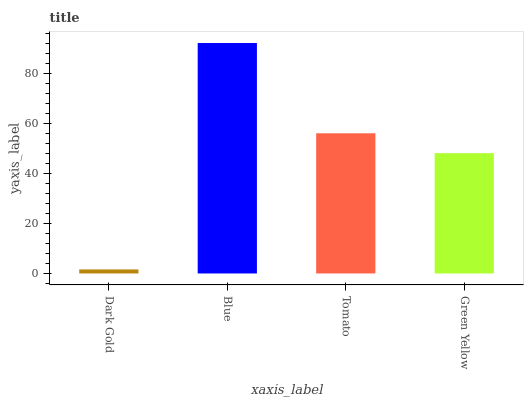Is Dark Gold the minimum?
Answer yes or no. Yes. Is Blue the maximum?
Answer yes or no. Yes. Is Tomato the minimum?
Answer yes or no. No. Is Tomato the maximum?
Answer yes or no. No. Is Blue greater than Tomato?
Answer yes or no. Yes. Is Tomato less than Blue?
Answer yes or no. Yes. Is Tomato greater than Blue?
Answer yes or no. No. Is Blue less than Tomato?
Answer yes or no. No. Is Tomato the high median?
Answer yes or no. Yes. Is Green Yellow the low median?
Answer yes or no. Yes. Is Blue the high median?
Answer yes or no. No. Is Blue the low median?
Answer yes or no. No. 